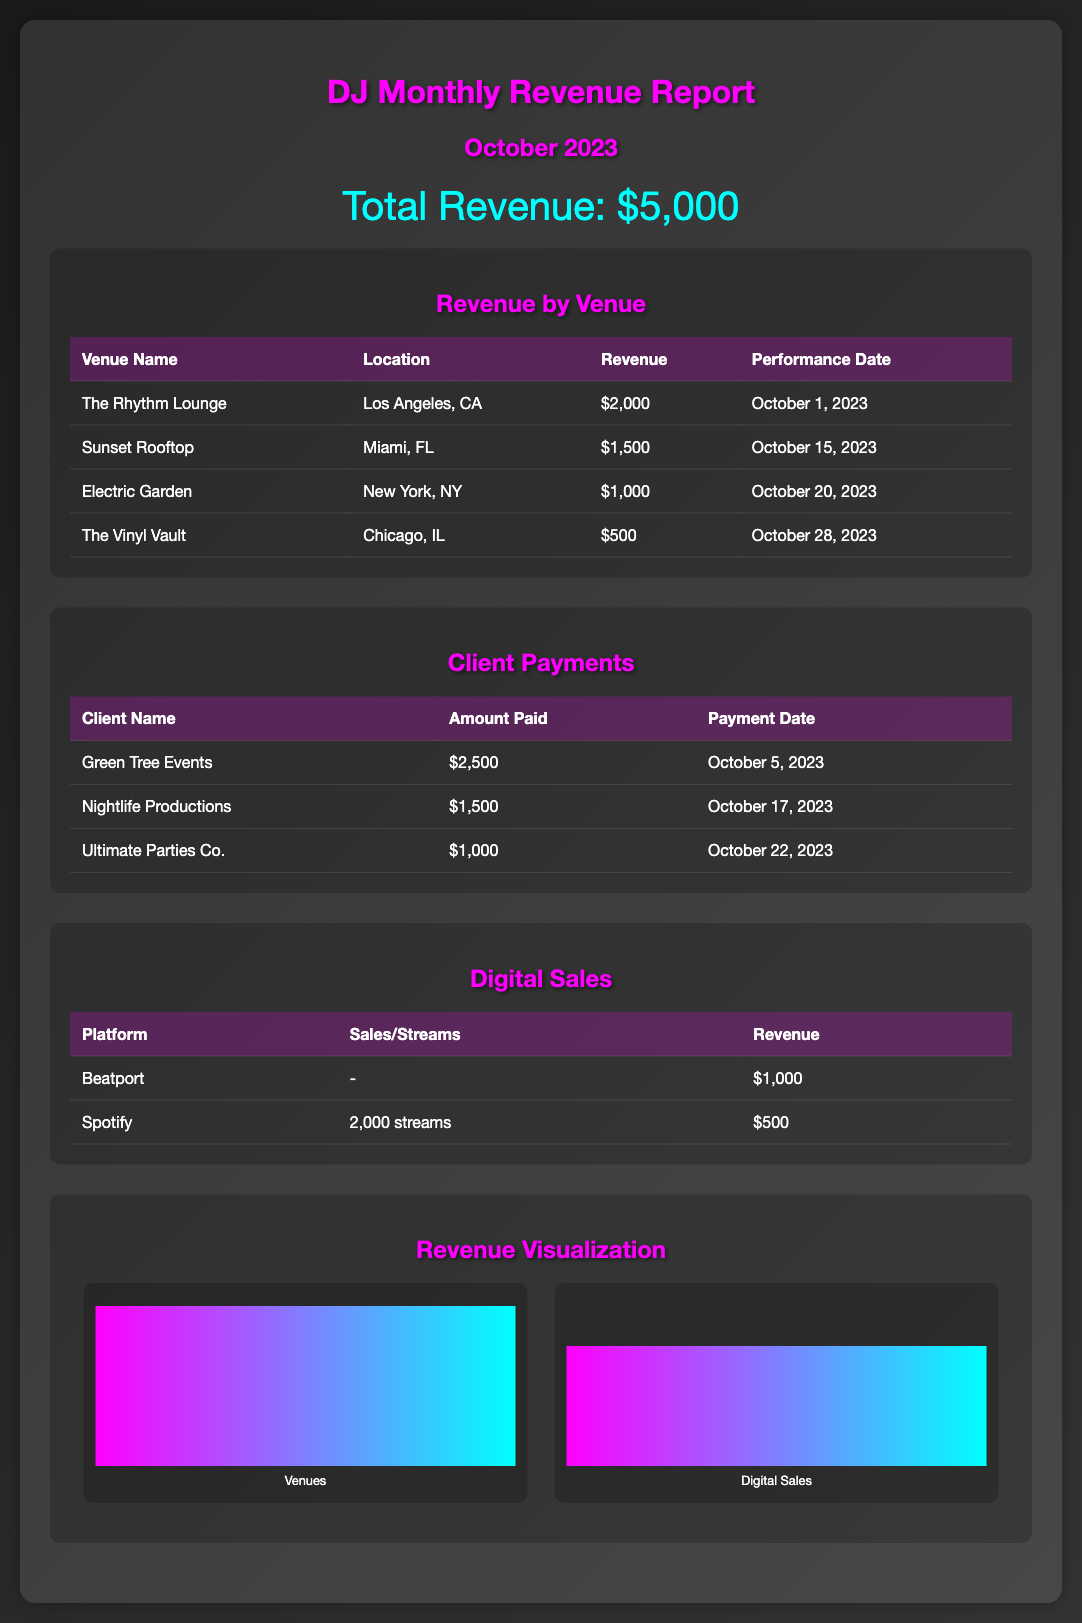What is the total revenue? The total revenue is clearly stated at the top of the report as $5,000.
Answer: $5,000 What venue generated the highest revenue? The table under "Revenue by Venue" shows that The Rhythm Lounge generated the highest revenue of $2,000.
Answer: The Rhythm Lounge How much did Sunset Rooftop earn? According to the "Revenue by Venue" section, Sunset Rooftop earned $1,500.
Answer: $1,500 What is the payment date for Green Tree Events? The payment information for Green Tree Events is listed as October 5, 2023 in the "Client Payments" table.
Answer: October 5, 2023 How much revenue was earned from Beatport? The "Digital Sales" section shows that revenue from Beatport is $1,000.
Answer: $1,000 What was the total revenue from digital sales? From the "Digital Sales" section, Beatport generated $1,000 and Spotify generated $500, making a total of $1,500 in digital sales.
Answer: $1,500 Which client paid the most? The "Client Payments" table indicates that Green Tree Events paid the highest amount, totaling $2,500.
Answer: $2,500 On which date was The Vinyl Vault performance? The performance date for The Vinyl Vault is stated as October 28, 2023 in the "Revenue by Venue" table.
Answer: October 28, 2023 How many streams did Spotify have? In the "Digital Sales" section, Spotify is stated to have 2,000 streams.
Answer: 2,000 streams 